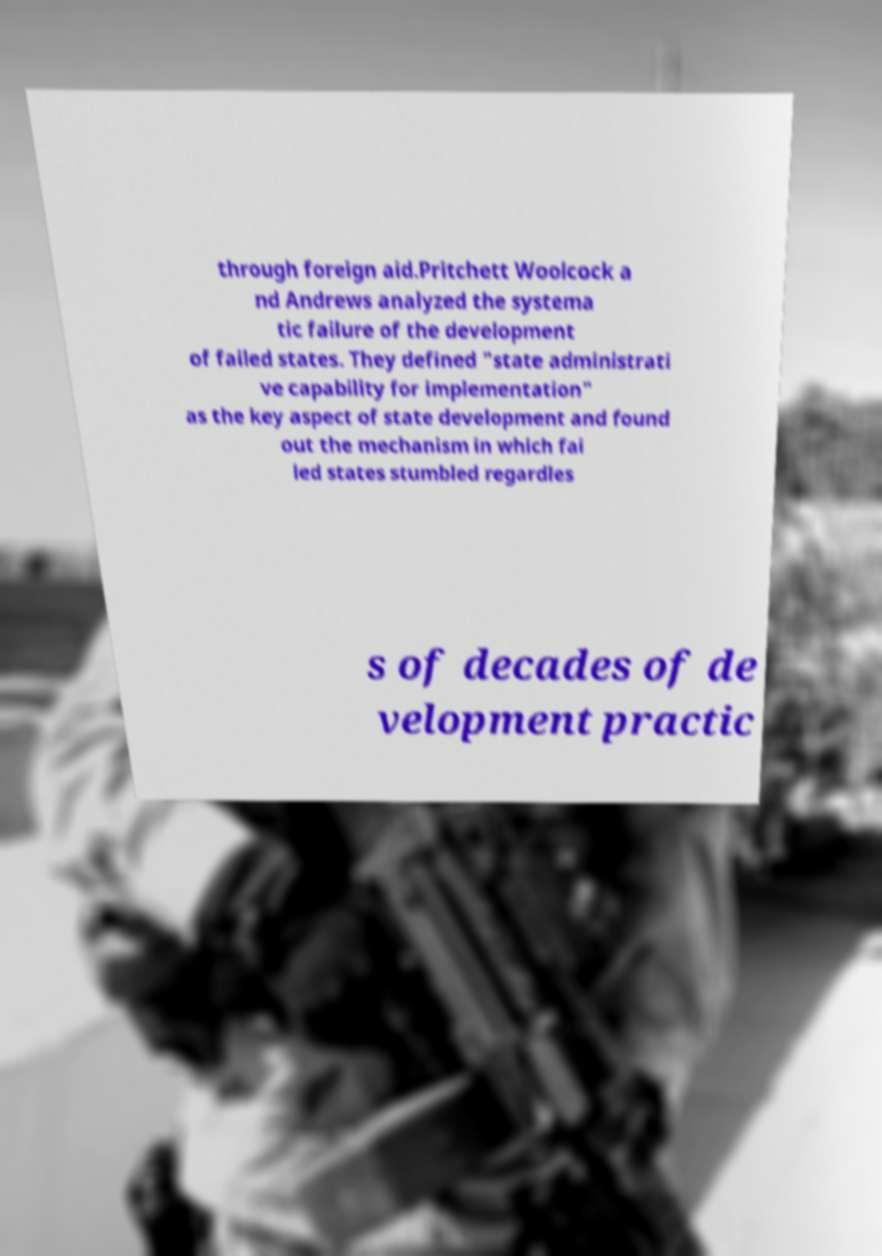Please read and relay the text visible in this image. What does it say? through foreign aid.Pritchett Woolcock a nd Andrews analyzed the systema tic failure of the development of failed states. They defined "state administrati ve capability for implementation" as the key aspect of state development and found out the mechanism in which fai led states stumbled regardles s of decades of de velopment practic 